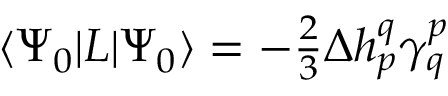Convert formula to latex. <formula><loc_0><loc_0><loc_500><loc_500>\begin{array} { r } { \langle { \Psi _ { 0 } } | L | { \Psi _ { 0 } } \rangle = - \frac { 2 } { 3 } \Delta h _ { p } ^ { q } \gamma _ { q } ^ { p } } \end{array}</formula> 